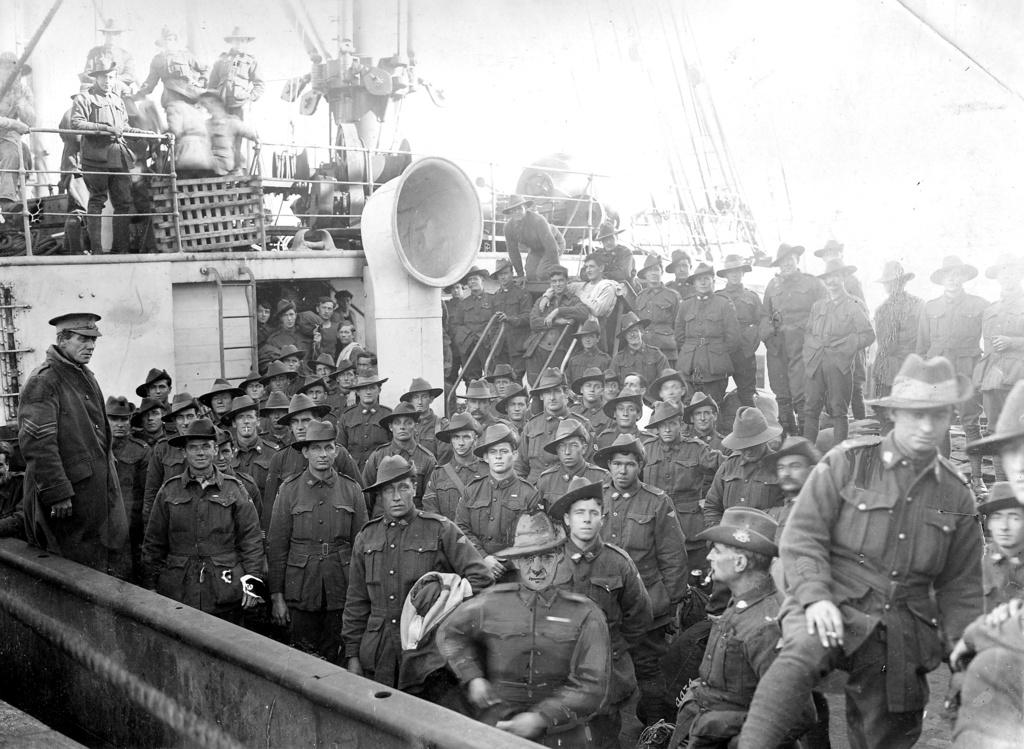What is the color scheme of the image? The image is black and white. Can you describe the people in the image? There is a group of people in the image. What type of structure can be seen in the image? There is a wall in the image. What other object is present in the image? There is a grille in the image. Are there any other objects visible in the image? Yes, there are other objects present in the image. What riddle is being solved by the people in the image? There is no riddle being solved in the image; it simply shows a group of people. What news is being discussed by the people in the image? There is no news being discussed in the image; it simply shows a group of people. 